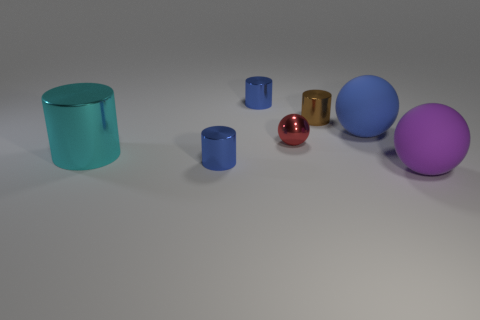Add 3 blue metallic objects. How many objects exist? 10 Subtract all cylinders. How many objects are left? 3 Subtract 0 green spheres. How many objects are left? 7 Subtract all brown matte objects. Subtract all blue balls. How many objects are left? 6 Add 4 cyan cylinders. How many cyan cylinders are left? 5 Add 4 purple rubber things. How many purple rubber things exist? 5 